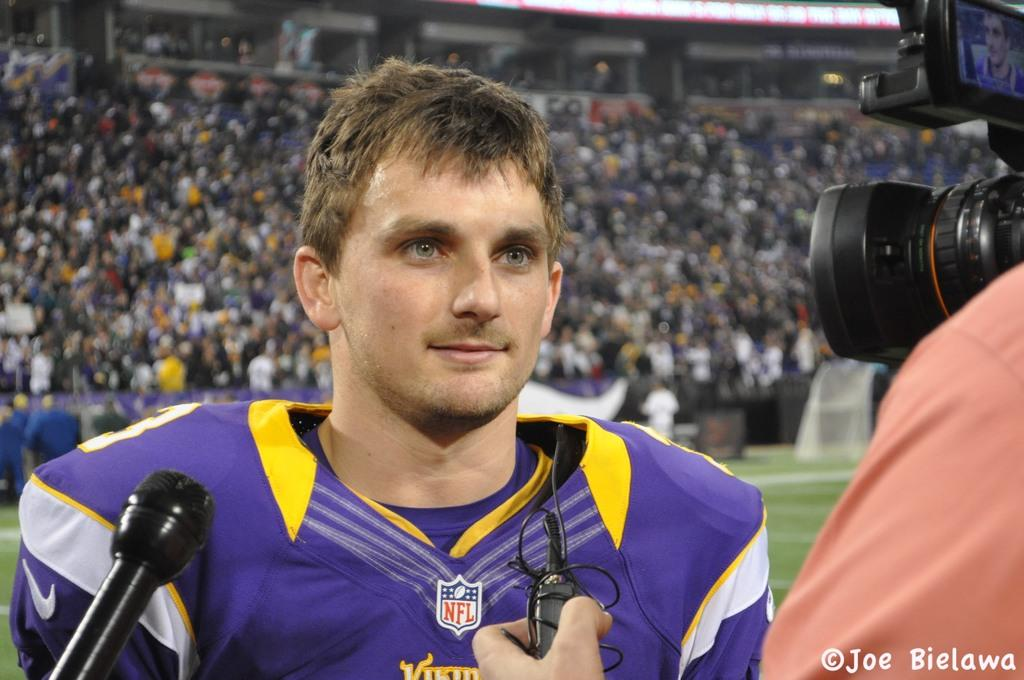<image>
Render a clear and concise summary of the photo. Man wearing a purple jersey which says NFL giving an interview. 